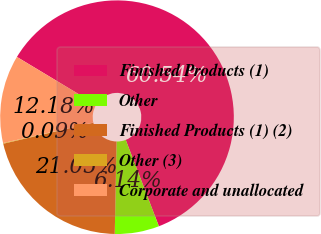Convert chart. <chart><loc_0><loc_0><loc_500><loc_500><pie_chart><fcel>Finished Products (1)<fcel>Other<fcel>Finished Products (1) (2)<fcel>Other (3)<fcel>Corporate and unallocated<nl><fcel>60.54%<fcel>6.14%<fcel>21.05%<fcel>0.09%<fcel>12.18%<nl></chart> 